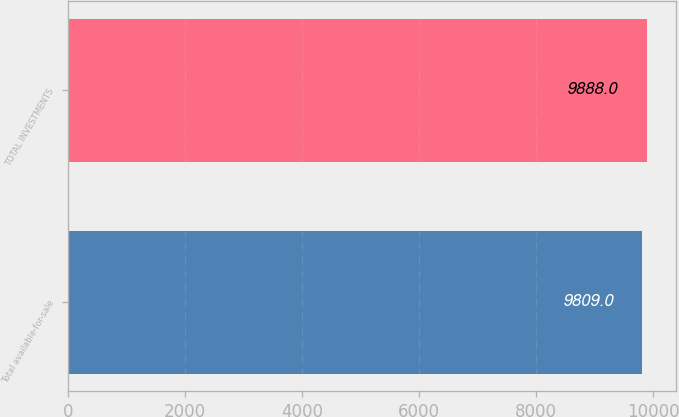Convert chart to OTSL. <chart><loc_0><loc_0><loc_500><loc_500><bar_chart><fcel>Total available-for-sale<fcel>TOTAL INVESTMENTS<nl><fcel>9809<fcel>9888<nl></chart> 